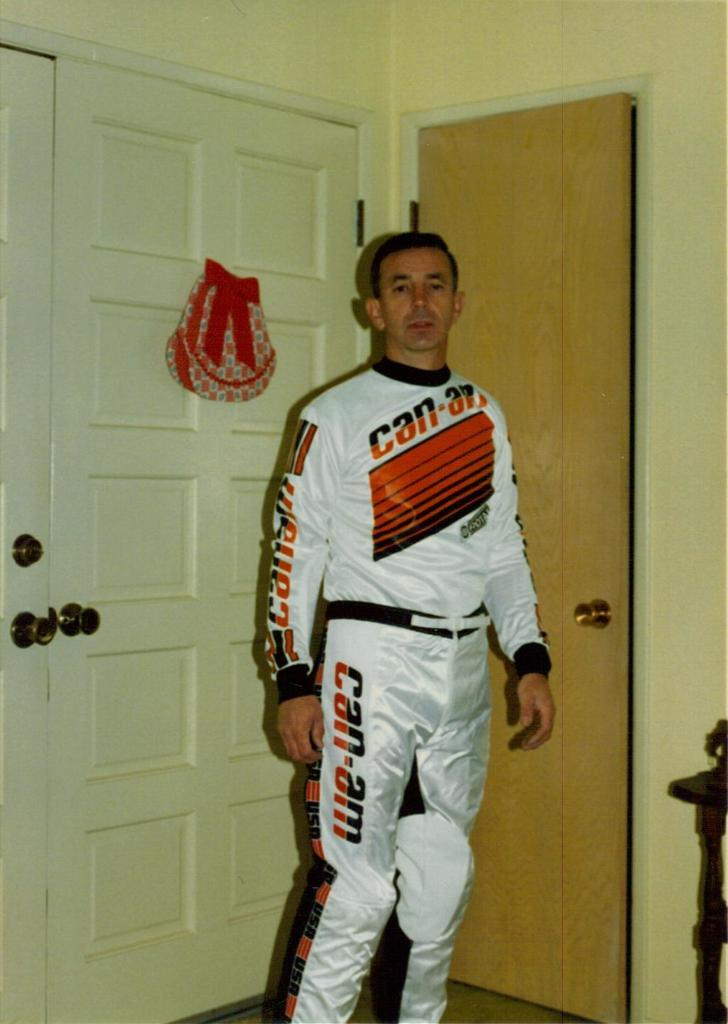<image>
Present a compact description of the photo's key features. A man wears a set of white coveralls that say can-am on the chest, leg, and arm. 